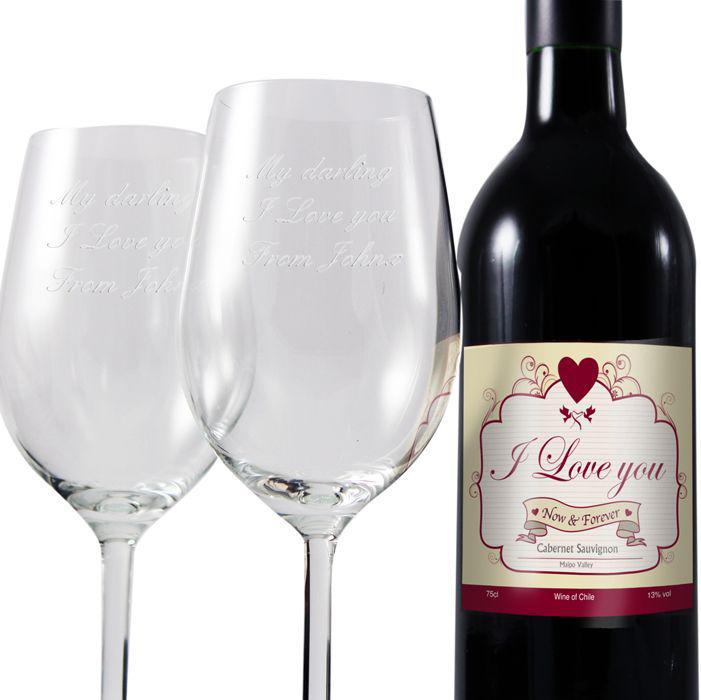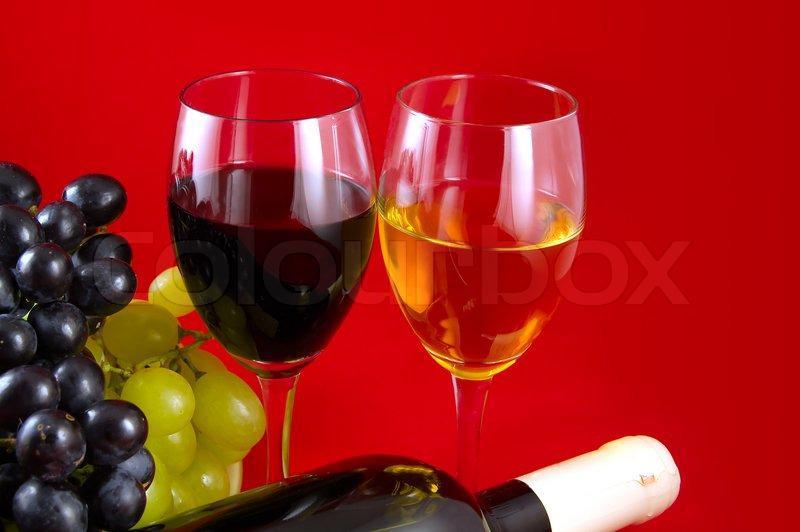The first image is the image on the left, the second image is the image on the right. Given the left and right images, does the statement "An image includes two glasses of wine, at least one bunch of grapes, and one wine bottle." hold true? Answer yes or no. Yes. The first image is the image on the left, the second image is the image on the right. Analyze the images presented: Is the assertion "Wine is being poured in a wine glass in one of the images." valid? Answer yes or no. No. 